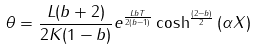Convert formula to latex. <formula><loc_0><loc_0><loc_500><loc_500>\theta = \frac { L ( b + 2 ) } { 2 K ( 1 - b ) } e ^ { \frac { L b T } { 2 ( b - 1 ) } } \cosh ^ { \frac { ( 2 - b ) } { 2 } } { ( \alpha X ) }</formula> 